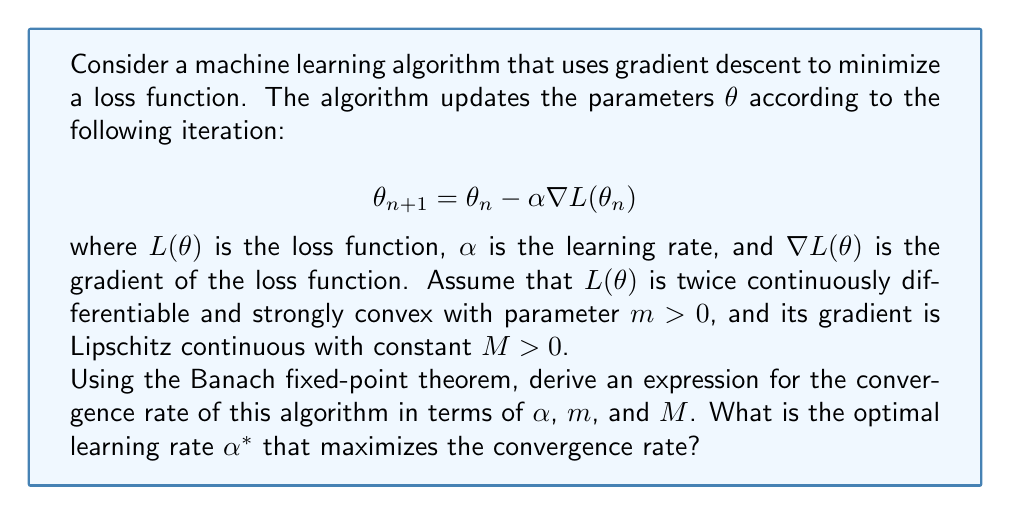What is the answer to this math problem? To solve this problem, we'll follow these steps:

1) First, we need to rewrite the iteration in the form of a fixed-point iteration:

   $$\theta_{n+1} = g(\theta_n)$$
   where $g(\theta) = \theta - \alpha \nabla L(\theta)$

2) For the Banach fixed-point theorem to apply, we need to show that $g$ is a contraction mapping. We'll use the mean value theorem:

   $$\|g(\theta) - g(\theta')\| = \|\theta - \theta' - \alpha(\nabla L(\theta) - \nabla L(\theta'))\|$$

3) Using the Lipschitz continuity of $\nabla L$:

   $$\|\nabla L(\theta) - \nabla L(\theta')\| \leq M\|\theta - \theta'\|$$

4) And the strong convexity of $L$:

   $$m\|\theta - \theta'\|^2 \leq (\nabla L(\theta) - \nabla L(\theta'))^T(\theta - \theta') \leq M\|\theta - \theta'\|^2$$

5) We can derive:

   $$\|g(\theta) - g(\theta')\| \leq \|I - \alpha\nabla^2 L(\xi)\| \cdot \|\theta - \theta'\|$$

   where $\xi$ is some point between $\theta$ and $\theta'$, and $I$ is the identity matrix.

6) Using the eigenvalue bounds from strong convexity and Lipschitz continuity:

   $$\|I - \alpha\nabla^2 L(\xi)\| \leq \max\{|1-\alpha m|, |1-\alpha M|\}$$

7) For $g$ to be a contraction, we need:

   $$\max\{|1-\alpha m|, |1-\alpha M|\} < 1$$

8) This is satisfied when $0 < \alpha < \frac{2}{M}$

9) The convergence rate is given by this maximum, so we want to minimize:

   $$\rho(\alpha) = \max\{|1-\alpha m|, |1-\alpha M|\}$$

10) The optimal $\alpha$ occurs when $1-\alpha m = -(1-\alpha M)$, which gives:

    $$\alpha^* = \frac{2}{m+M}$$

11) The corresponding convergence rate is:

    $$\rho(\alpha^*) = \frac{M-m}{M+m}$$
Answer: Optimal learning rate: $\alpha^* = \frac{2}{m+M}$; Convergence rate: $\rho = \frac{M-m}{M+m}$ 